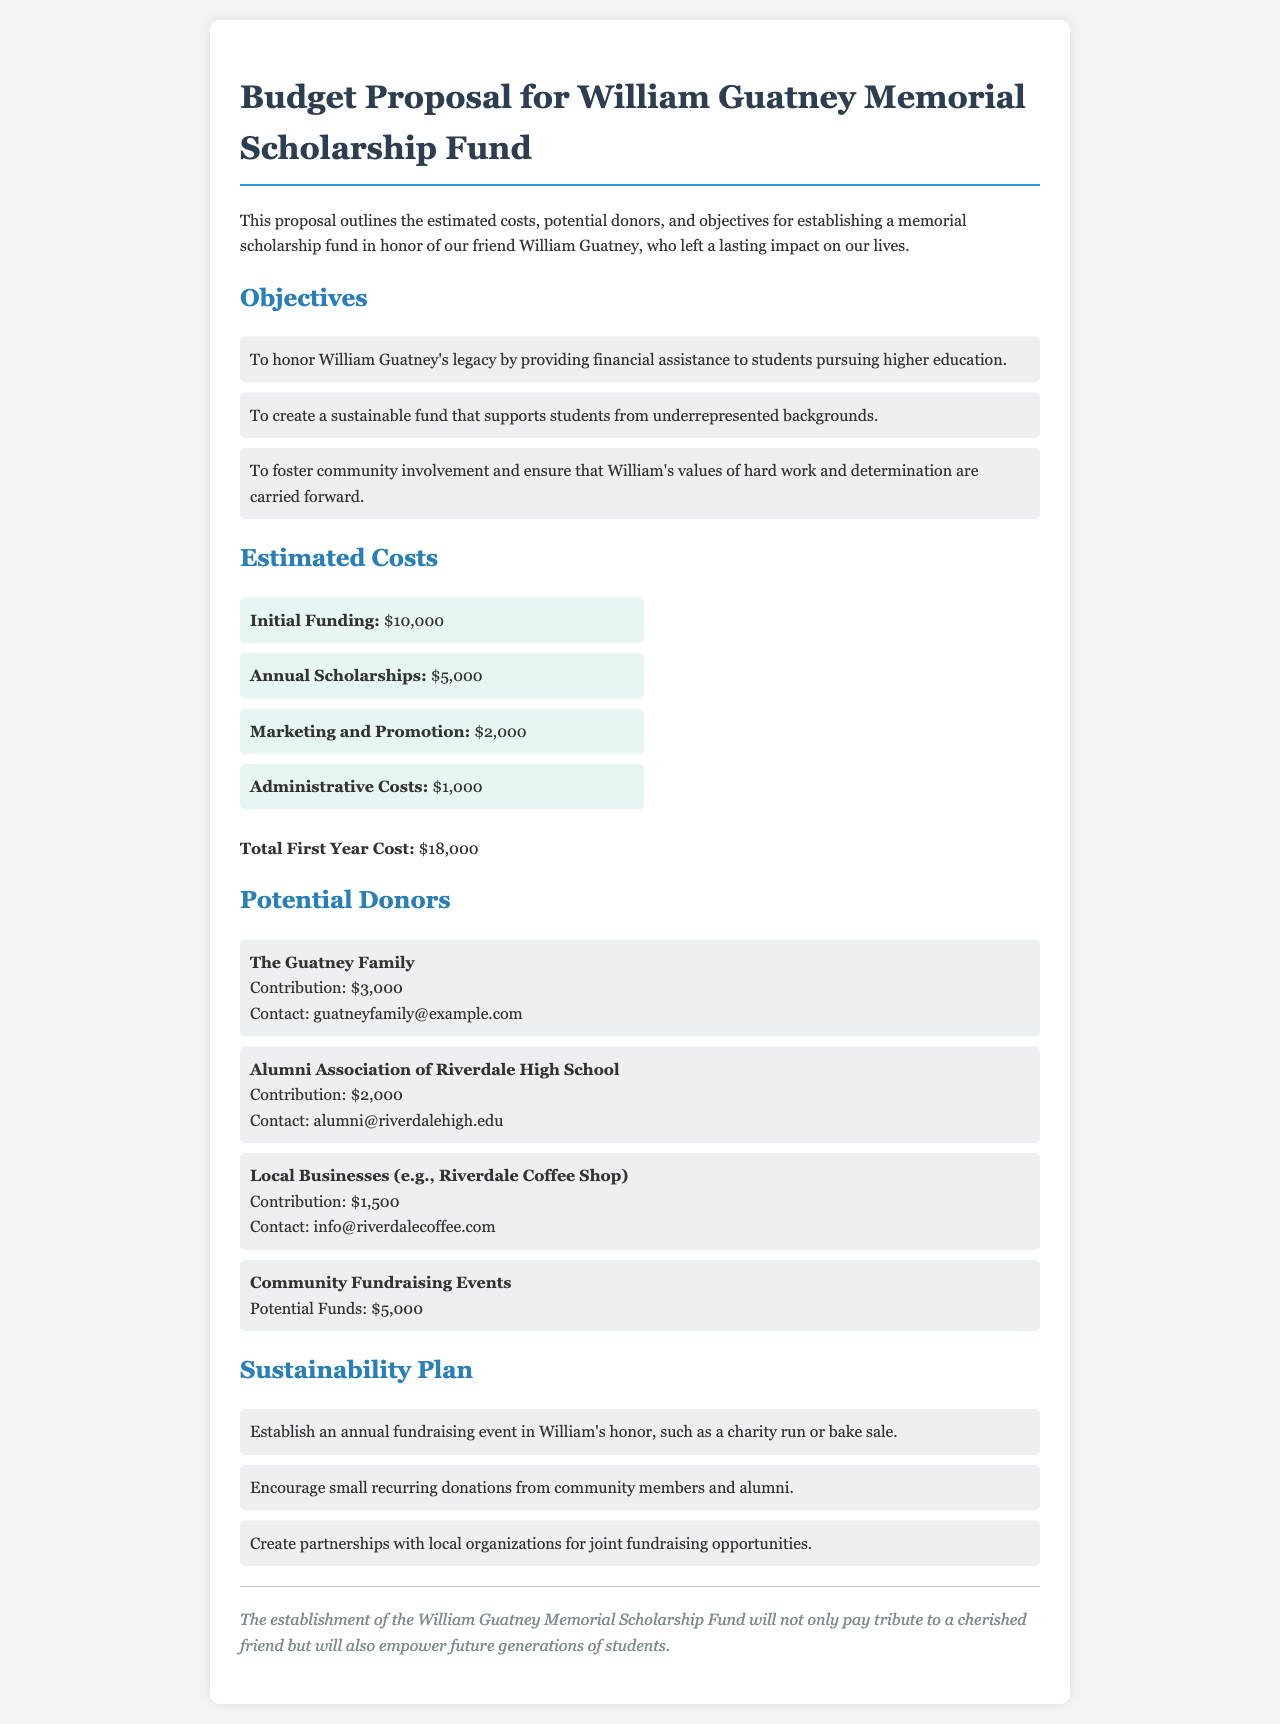What is the total first year cost? The total first year cost is provided at the end of the Estimated Costs section, which sums to $18,000.
Answer: $18,000 Who is the contact for the Guatney Family? The contact information for the Guatney Family is listed under Potential Donors.
Answer: guatneyfamily@example.com What is one objective of the scholarship fund? Several objectives are listed, one of which is to provide financial assistance to students pursuing higher education.
Answer: To honor William Guatney's legacy by providing financial assistance to students pursuing higher education How much will the Alumni Association of Riverdale High School contribute? This information is provided under Potential Donors, specifying the amount the Alumni Association will contribute.
Answer: $2,000 What annual fundraising event is suggested? The document mentions establishing an annual fundraising event in William's honor as part of the sustainability plan, like a charity run.
Answer: charity run 